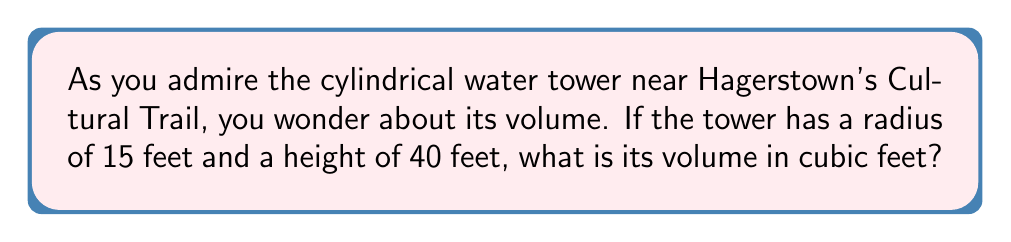Solve this math problem. Let's approach this step-by-step using the formula for the volume of a cylinder:

1) The formula for the volume of a cylinder is:
   $$V = \pi r^2 h$$
   where $V$ is volume, $r$ is radius, and $h$ is height.

2) We're given:
   $r = 15$ feet
   $h = 40$ feet

3) Let's substitute these values into our formula:
   $$V = \pi (15\text{ ft})^2 (40\text{ ft})$$

4) First, let's calculate $r^2$:
   $$15^2 = 225$$

5) Now our equation looks like:
   $$V = \pi (225\text{ ft}^2) (40\text{ ft})$$

6) Multiply the numbers:
   $$V = \pi (9000\text{ ft}^3)$$

7) Multiply by $\pi$:
   $$V \approx 28,274.33\text{ ft}^3$$

8) Rounding to the nearest cubic foot:
   $$V \approx 28,274\text{ ft}^3$$
Answer: $28,274\text{ ft}^3$ 